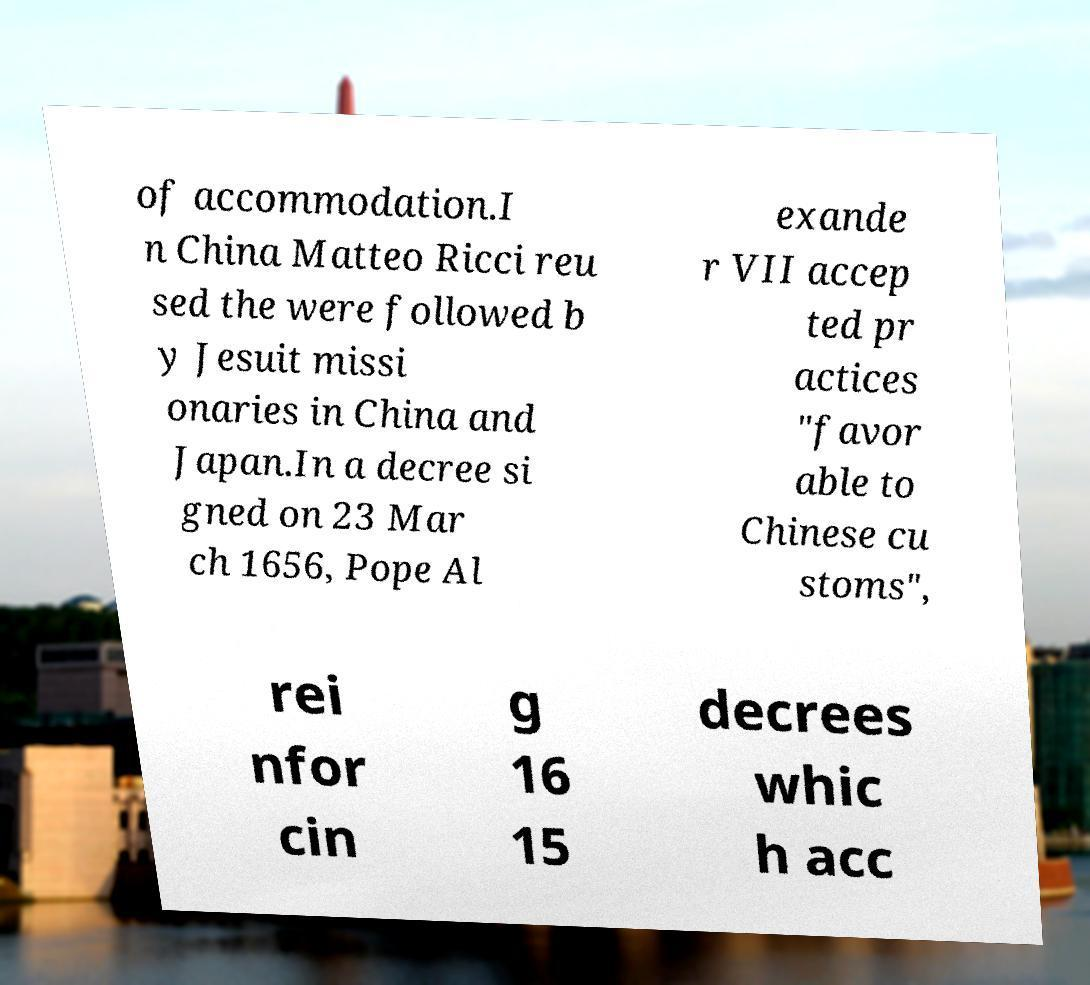Could you extract and type out the text from this image? of accommodation.I n China Matteo Ricci reu sed the were followed b y Jesuit missi onaries in China and Japan.In a decree si gned on 23 Mar ch 1656, Pope Al exande r VII accep ted pr actices "favor able to Chinese cu stoms", rei nfor cin g 16 15 decrees whic h acc 